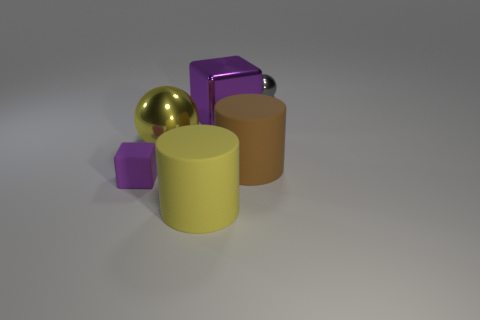How many things are large cylinders that are to the left of the brown matte cylinder or purple matte blocks?
Your response must be concise. 2. The brown thing is what size?
Provide a succinct answer. Large. What is the material of the big yellow object that is in front of the ball that is in front of the gray metallic object?
Keep it short and to the point. Rubber. Do the metal block behind the purple matte thing and the tiny ball have the same size?
Your response must be concise. No. Are there any large matte cylinders of the same color as the big sphere?
Offer a terse response. Yes. What number of things are balls right of the big purple shiny object or metallic objects that are in front of the gray sphere?
Keep it short and to the point. 3. Is the small metallic thing the same color as the small rubber cube?
Make the answer very short. No. What material is the other thing that is the same color as the small matte thing?
Your answer should be very brief. Metal. Is the number of yellow things that are behind the brown rubber object less than the number of gray metal spheres that are in front of the matte block?
Make the answer very short. No. Are the tiny gray thing and the tiny purple thing made of the same material?
Ensure brevity in your answer.  No. 